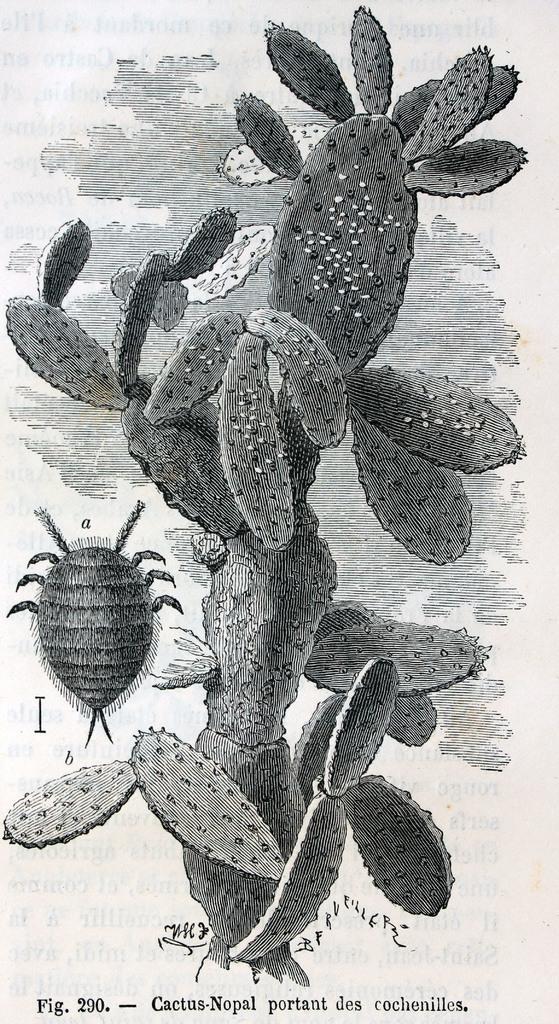Please provide a concise description of this image. In this picture we can see a cactus plant and an insect. 